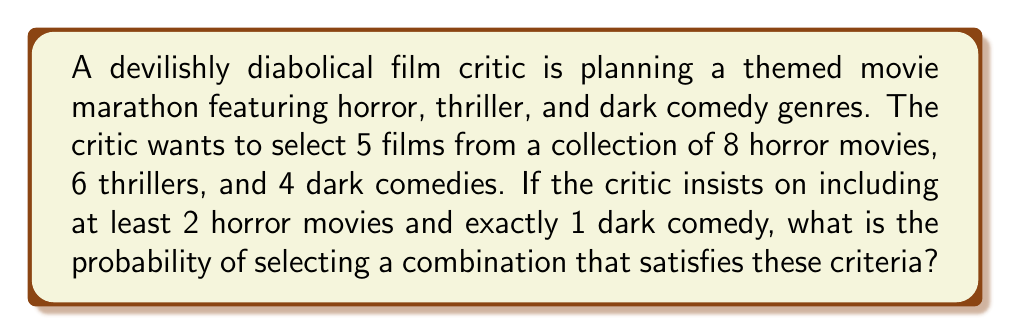Provide a solution to this math problem. Let's approach this step-by-step:

1) First, we need to calculate the total number of ways to select 5 films from 18 films (8 + 6 + 4). This is our total sample space:

   $$\binom{18}{5} = \frac{18!}{5!(18-5)!} = 8568$$

2) Now, let's calculate the number of ways to select films that meet the criteria:

   a) We need at least 2 horror movies and exactly 1 dark comedy. This means we can have either 2 or 3 horror movies.

   b) Case 1: 2 horror movies, 1 dark comedy, 2 thrillers
      - Select 2 horror movies: $\binom{8}{2}$
      - Select 1 dark comedy: $\binom{4}{1}$
      - Select 2 thrillers: $\binom{6}{2}$
      Total for Case 1: $\binom{8}{2} \times \binom{4}{1} \times \binom{6}{2}$

   c) Case 2: 3 horror movies, 1 dark comedy, 1 thriller
      - Select 3 horror movies: $\binom{8}{3}$
      - Select 1 dark comedy: $\binom{4}{1}$
      - Select 1 thriller: $\binom{6}{1}$
      Total for Case 2: $\binom{8}{3} \times \binom{4}{1} \times \binom{6}{1}$

3) The total number of favorable outcomes is the sum of Case 1 and Case 2:

   $\binom{8}{2} \times \binom{4}{1} \times \binom{6}{2} + \binom{8}{3} \times \binom{4}{1} \times \binom{6}{1}$

   $= (28 \times 4 \times 15) + (56 \times 4 \times 6)$
   $= 1680 + 1344 = 3024$

4) The probability is the number of favorable outcomes divided by the total number of possible outcomes:

   $$P = \frac{3024}{8568} = \frac{126}{357} \approx 0.3529$$
Answer: $\frac{126}{357}$ or approximately $0.3529$ or $35.29\%$ 